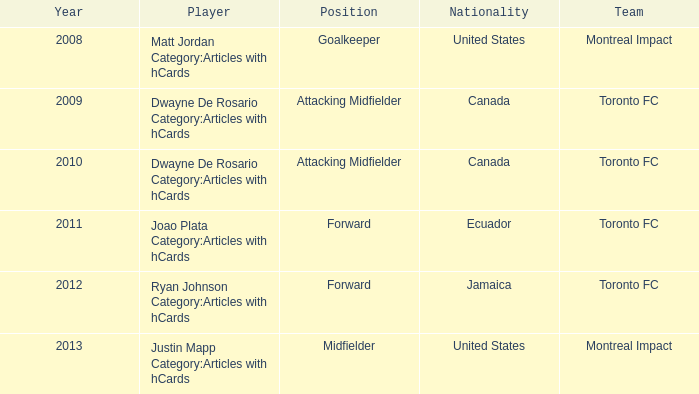After 2009, what's the nationality of a player named Dwayne de Rosario Category:articles with hcards? Canada. 